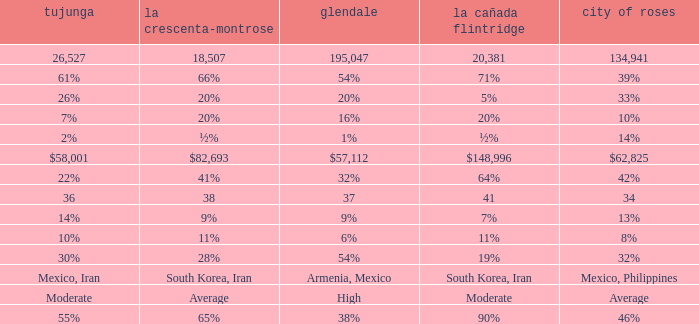What is the percentage of La Canada Flintridge when Tujunga is 7%? 20%. 